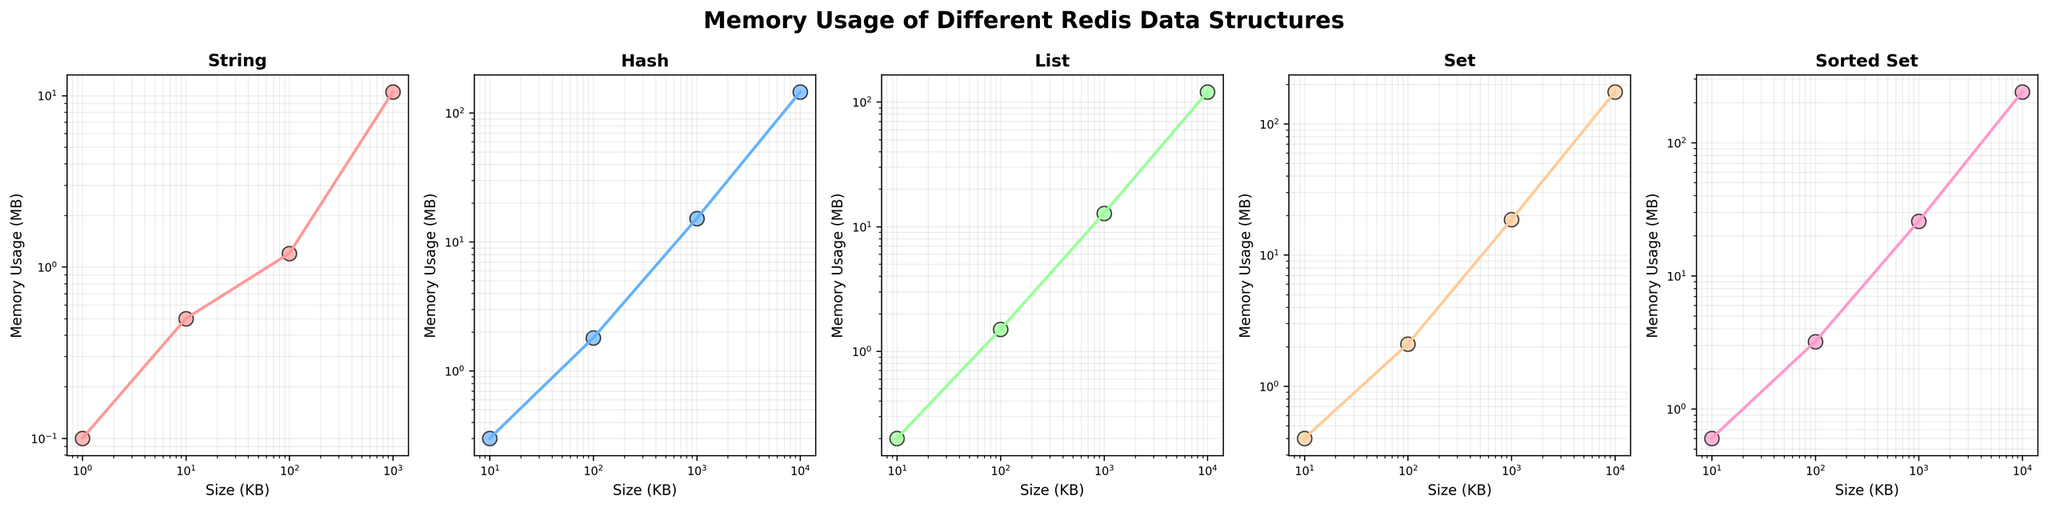How does the memory usage of Hash compare with that of List when the size is 1000 KB? Look at the memory usage for Hash and List at 1000 KB. For Hash, the memory usage is 15.2 MB, and for List, it's 12.8 MB. Thus, Hash uses more memory than List.
Answer: Hash uses more memory What is the visual difference between the data points for the String and Sorted Set at 1000 KB? Notice the color and position of the data points for String and Sorted Set at 1000 KB. The String data point is likely located lower and colored differently than the Sorted Set. The String (red) is lower on the plot, indicating less memory usage compared to the Sorted Set (purple).
Answer: Sorted Set has a higher memory usage Which data structure generally has the lowest memory usage as the size increases? Observe all subplots and the positioning of the lines or points at increasing sizes. The String data structure consistently shows the lowest position on the y-axis (memory usage axis) for increasing sizes.
Answer: String What's the difference in memory usage between Set and Hash at 10000 KB? Look at the memory usage for Set and Hash at 10000 KB. For Set, it is 175.3 MB, and for Hash, it is 145.6 MB. Subtract Hash's memory usage from Set's memory usage to find the difference: 175.3 - 145.6 = 29.7 MB.
Answer: 29.7 MB Which data structure exhibits the steepest increase in memory usage from 1000 KB to 10000 KB? Compare the slopes of the lines in each subplot from 1000 KB to 10000 KB. The Sorted Set shows the steepest increase from a memory usage of 25.7 MB at 1000 KB to 240.1 MB at 10000 KB, indicating the most significant change.
Answer: Sorted Set How does the memory usage of the List structure change from 10 KB to 100 KB? Check the memory usage points for the List data structure at 10 KB (0.2 MB) and 100 KB (1.5 MB). Subtract the former from the latter to find the change in memory usage: 1.5 - 0.2 = 1.3 MB.
Answer: Increases by 1.3 MB Between Hash and Set, which data structure has more consistent memory usage growth? Look at the shapes of the lines or patterns of points between Hash and Set across different sizes. Hash displays a more linear pattern, while Set shows a steeper and quicker increase. Hence, Hash has more consistent growth.
Answer: Hash At what size does the Sorted Set reach roughly 10 times the memory usage of the List? Identify when the Sorted Set's memory usage is approximately 10 times higher than that of the List. List at 10000 KB uses 120.4 MB, so 10 times would be around 1204 MB. This isn't reached by Sorted Set in the given data, thus Sorted Set never reaches 10 times List's memory usage in the specified range.
Answer: Not reached What can you infer about the behavior of memory usage between 100 KB to 1000 KB across all data structures? Observe the lines or points across all subplots between 100 KB and 1000 KB. Memory usage increases for all data structures, with varying degrees of steepness, indicating larger sizes significantly impact memory usage.
Answer: All increase in memory usage How does the memory usage of Strings at 10 KB compare to that of Sorted Sets at 10 KB? Find the memory usage values for String and Sorted Set at 10 KB. String's memory usage is 0.1 MB, while Sorted Set's is 0.6 MB. Thus, Sorted Set uses more memory than String.
Answer: Sorted Set uses more memory 